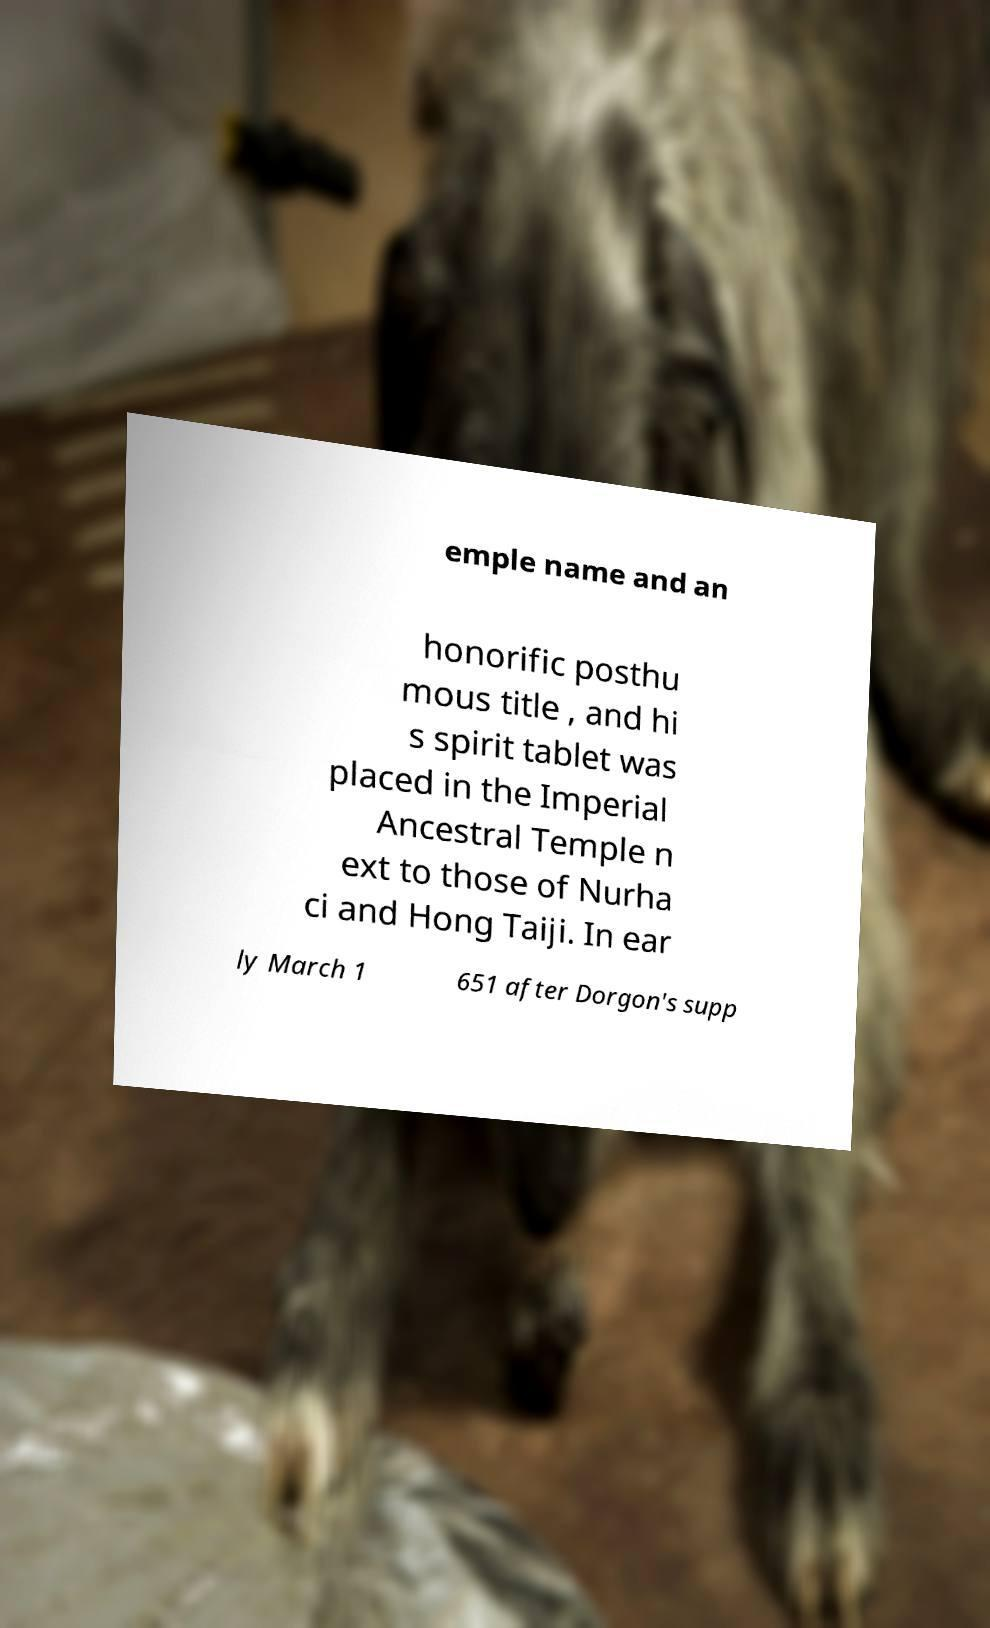Could you extract and type out the text from this image? emple name and an honorific posthu mous title , and hi s spirit tablet was placed in the Imperial Ancestral Temple n ext to those of Nurha ci and Hong Taiji. In ear ly March 1 651 after Dorgon's supp 